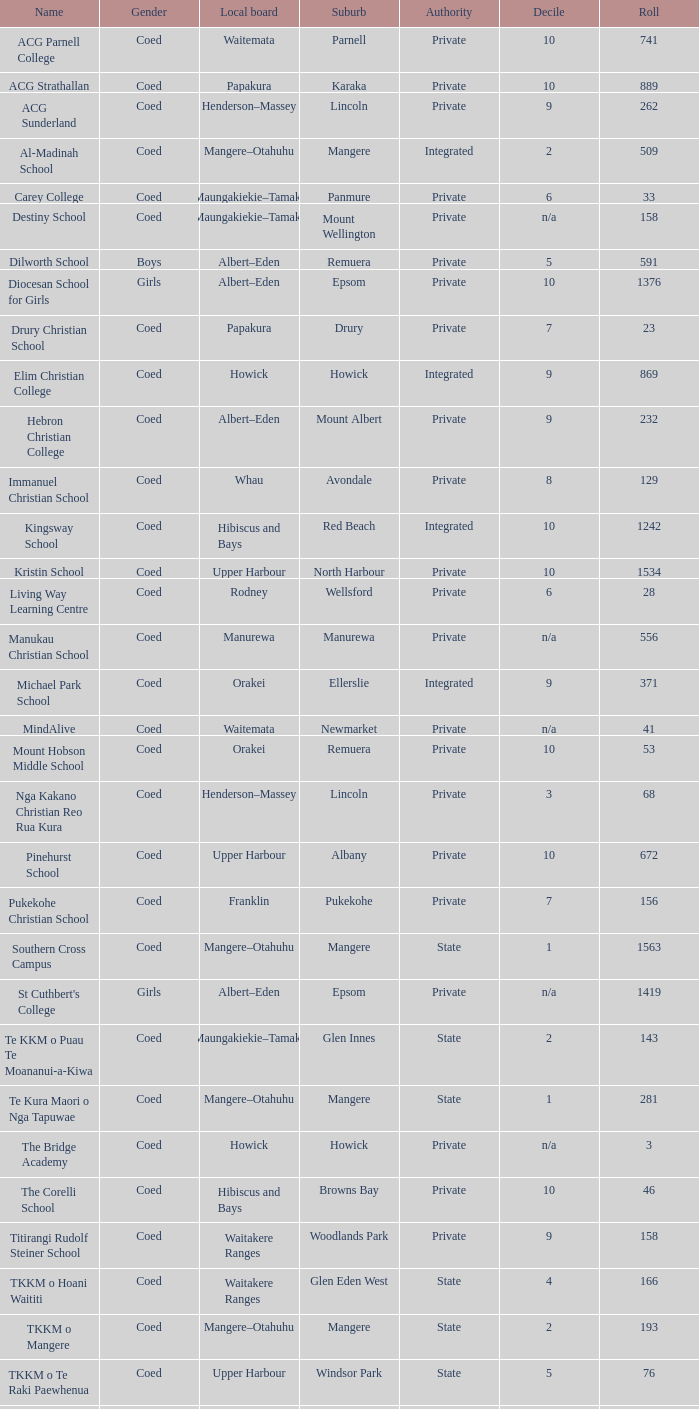What is the name that represents both private authority and the hibiscus and bays local board? The Corelli School. 